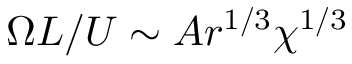<formula> <loc_0><loc_0><loc_500><loc_500>\Omega L / U \sim A r ^ { 1 / 3 } \chi ^ { 1 / 3 }</formula> 